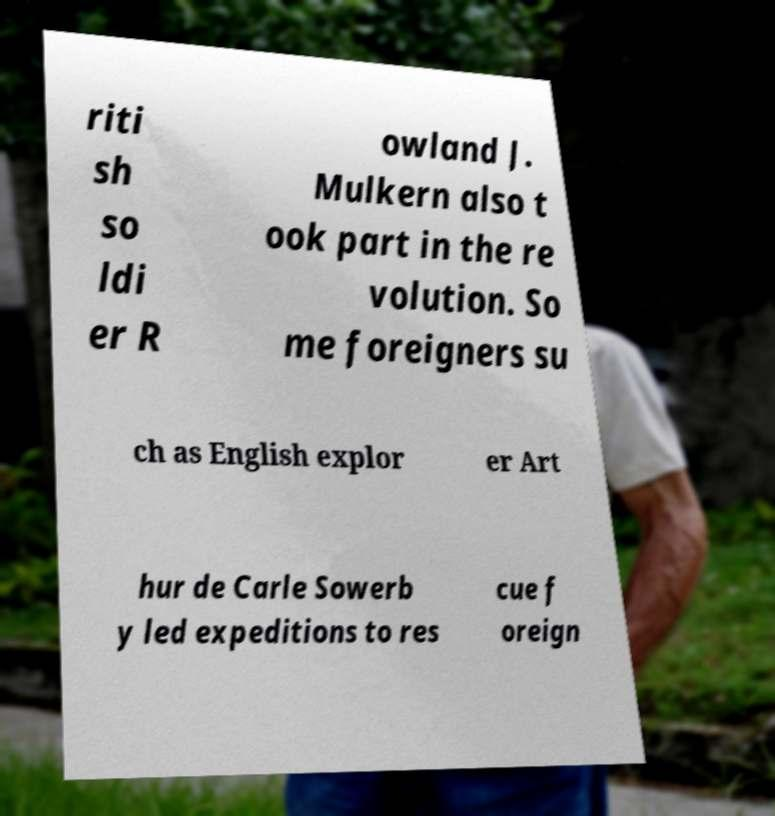For documentation purposes, I need the text within this image transcribed. Could you provide that? riti sh so ldi er R owland J. Mulkern also t ook part in the re volution. So me foreigners su ch as English explor er Art hur de Carle Sowerb y led expeditions to res cue f oreign 